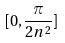Convert formula to latex. <formula><loc_0><loc_0><loc_500><loc_500>[ 0 , \frac { \pi } { 2 n ^ { 2 } } ]</formula> 